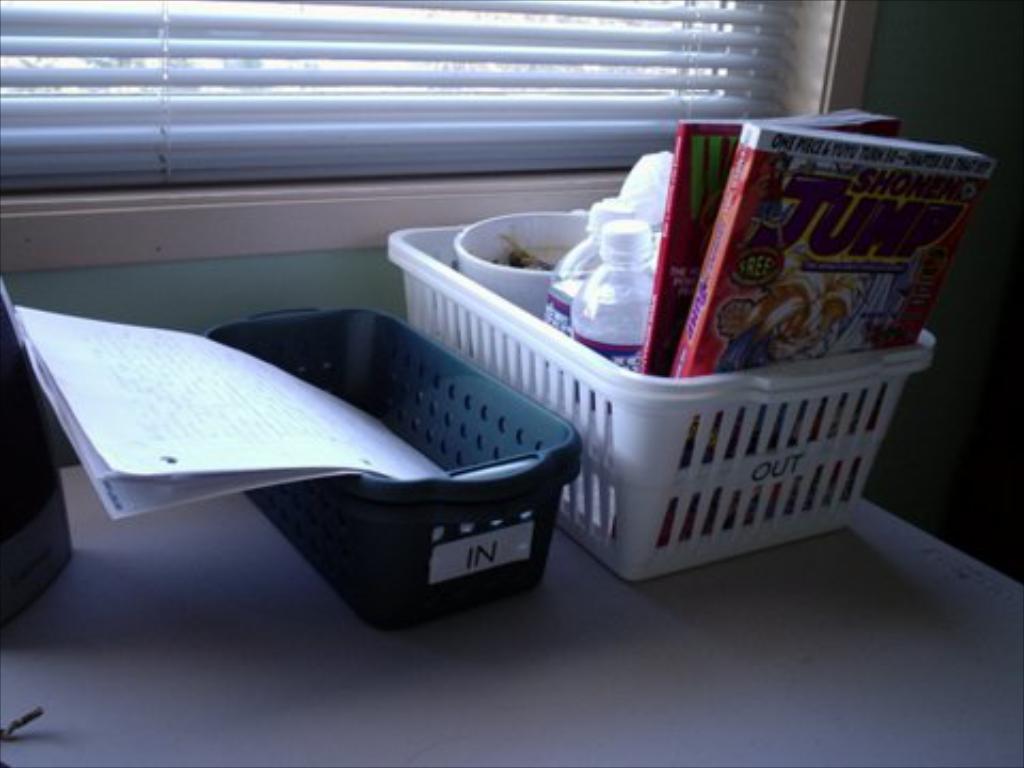Describe this image in one or two sentences. In the picture we can see a table which is white in color and on it we can see a basket with some books, and water bottles and beside it we can see another basket with some papers in it and behind it we can see a wall with a window. 